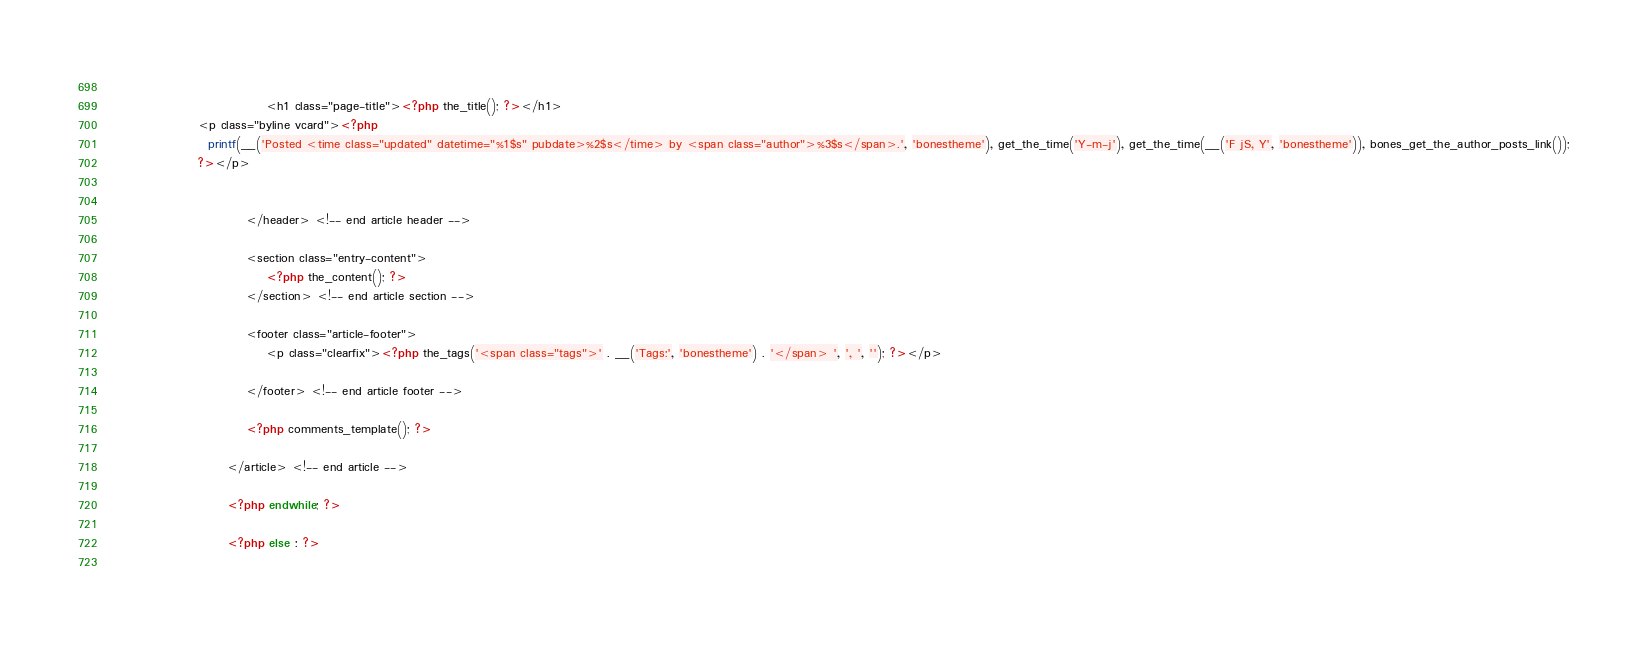Convert code to text. <code><loc_0><loc_0><loc_500><loc_500><_PHP_>							
							    <h1 class="page-title"><?php the_title(); ?></h1>
                  <p class="byline vcard"><?php
                    printf(__('Posted <time class="updated" datetime="%1$s" pubdate>%2$s</time> by <span class="author">%3$s</span>.', 'bonestheme'), get_the_time('Y-m-j'), get_the_time(__('F jS, Y', 'bonestheme')), bones_get_the_author_posts_link());
                  ?></p>

						
						    </header> <!-- end article header -->
					
						    <section class="entry-content">
							    <?php the_content(); ?>
						    </section> <!-- end article section -->
						
						    <footer class="article-footer">
							    <p class="clearfix"><?php the_tags('<span class="tags">' . __('Tags:', 'bonestheme') . '</span> ', ', ', ''); ?></p>
							
						    </footer> <!-- end article footer -->
						    
						    <?php comments_template(); ?>
					
					    </article> <!-- end article -->
					
					    <?php endwhile; ?>	
					
					    <?php else : ?>
					</code> 